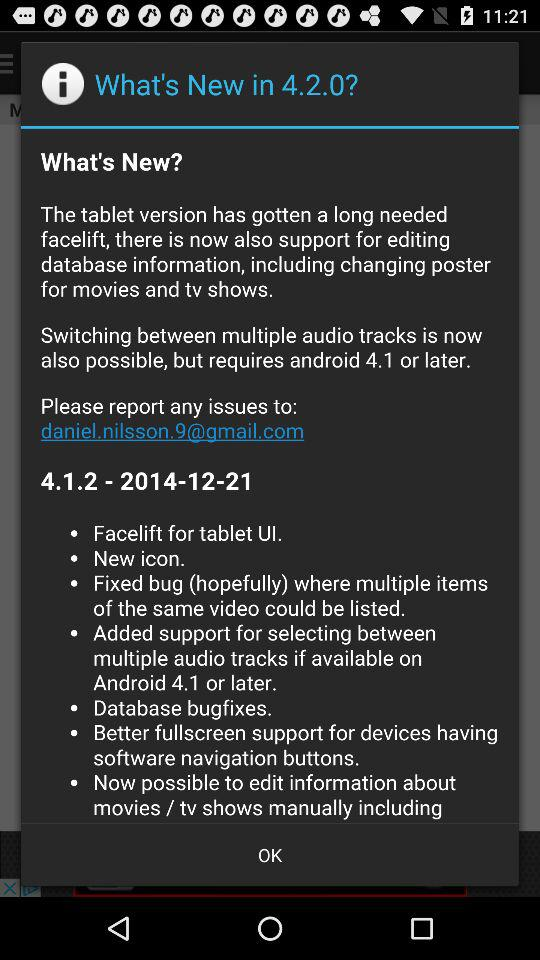What is the new version number? The new version number is 4.2.0. 